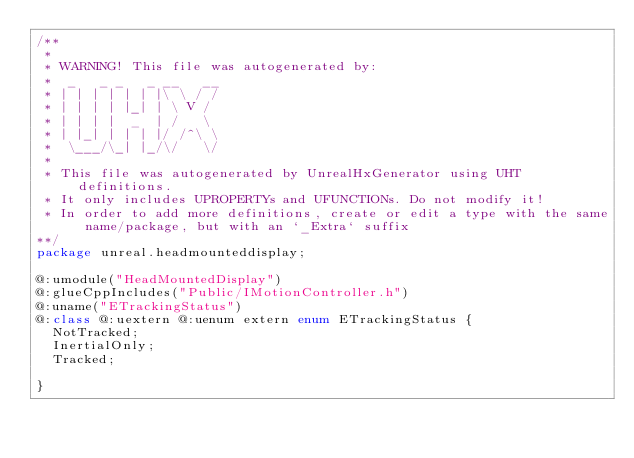Convert code to text. <code><loc_0><loc_0><loc_500><loc_500><_Haxe_>/**
 * 
 * WARNING! This file was autogenerated by: 
 *  _   _ _   _ __   __ 
 * | | | | | | |\ \ / / 
 * | | | | |_| | \ V /  
 * | | | |  _  | /   \  
 * | |_| | | | |/ /^\ \ 
 *  \___/\_| |_/\/   \/ 
 * 
 * This file was autogenerated by UnrealHxGenerator using UHT definitions.
 * It only includes UPROPERTYs and UFUNCTIONs. Do not modify it!
 * In order to add more definitions, create or edit a type with the same name/package, but with an `_Extra` suffix
**/
package unreal.headmounteddisplay;

@:umodule("HeadMountedDisplay")
@:glueCppIncludes("Public/IMotionController.h")
@:uname("ETrackingStatus")
@:class @:uextern @:uenum extern enum ETrackingStatus {
  NotTracked;
  InertialOnly;
  Tracked;
  
}
</code> 